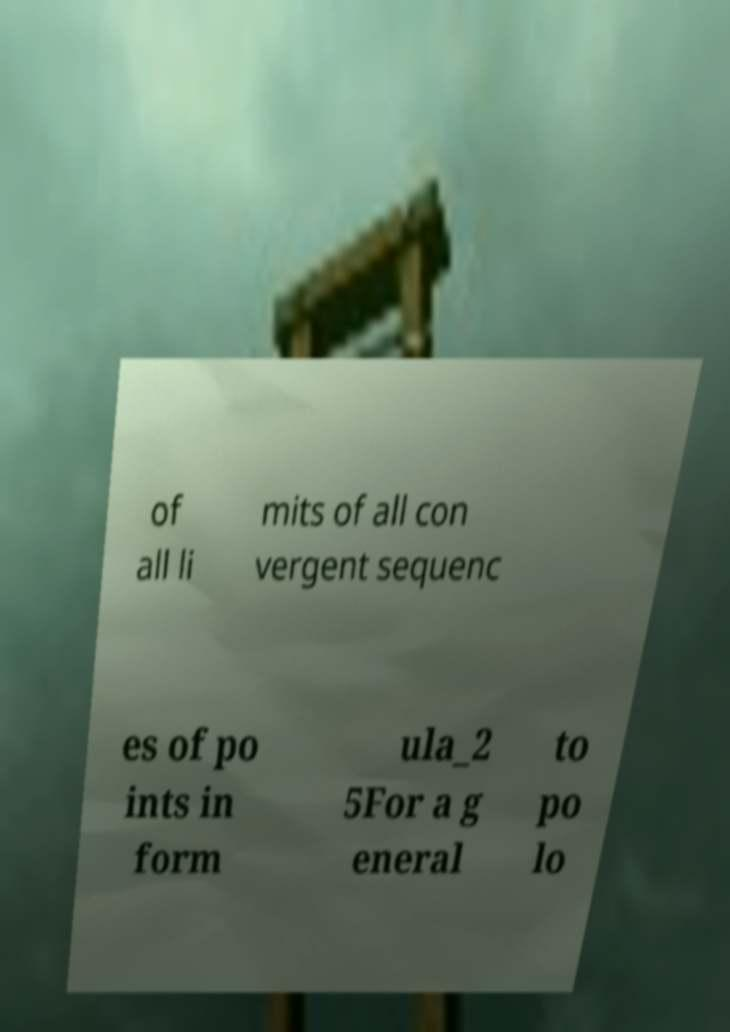Could you extract and type out the text from this image? of all li mits of all con vergent sequenc es of po ints in form ula_2 5For a g eneral to po lo 